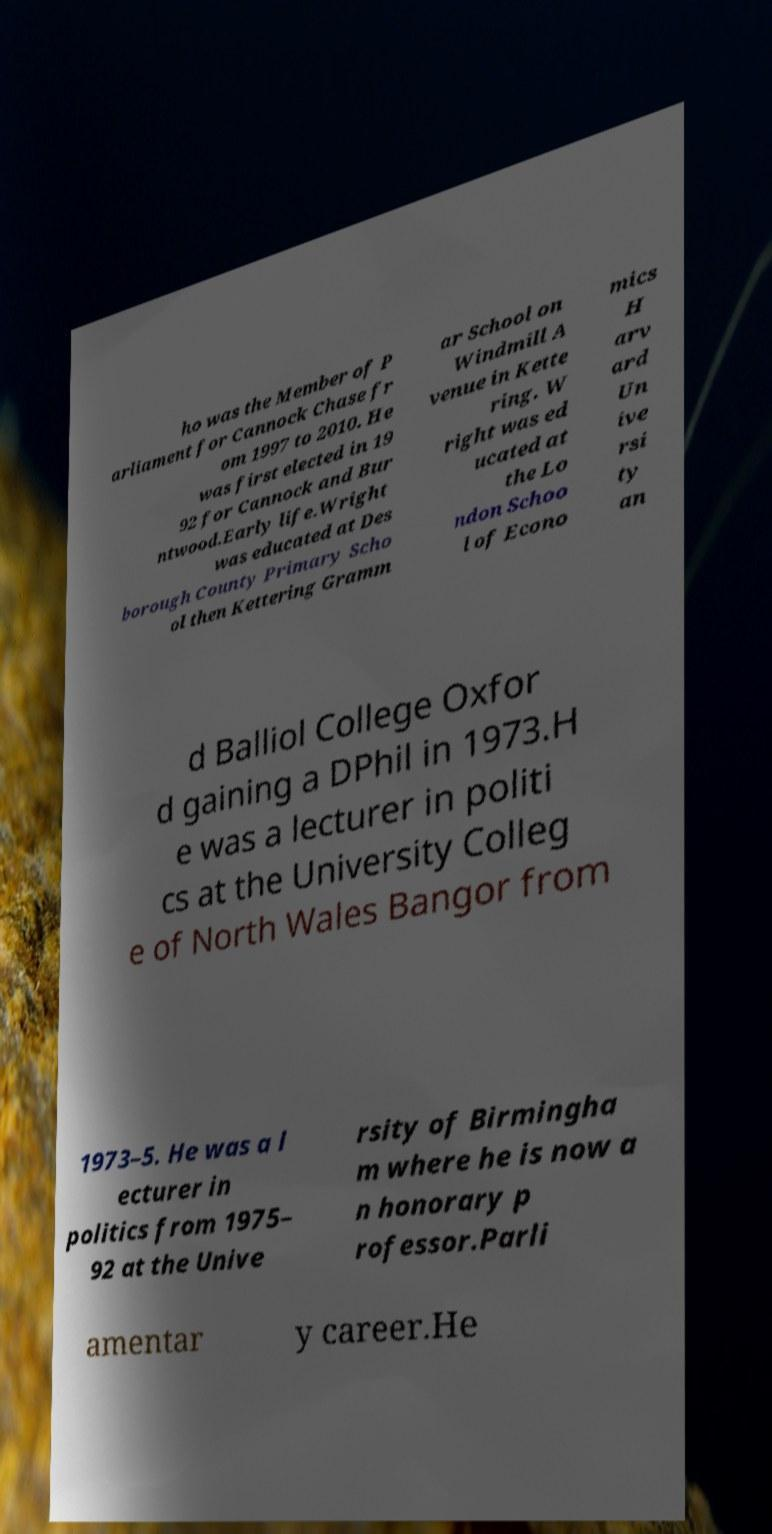Can you accurately transcribe the text from the provided image for me? ho was the Member of P arliament for Cannock Chase fr om 1997 to 2010. He was first elected in 19 92 for Cannock and Bur ntwood.Early life.Wright was educated at Des borough County Primary Scho ol then Kettering Gramm ar School on Windmill A venue in Kette ring. W right was ed ucated at the Lo ndon Schoo l of Econo mics H arv ard Un ive rsi ty an d Balliol College Oxfor d gaining a DPhil in 1973.H e was a lecturer in politi cs at the University Colleg e of North Wales Bangor from 1973–5. He was a l ecturer in politics from 1975– 92 at the Unive rsity of Birmingha m where he is now a n honorary p rofessor.Parli amentar y career.He 